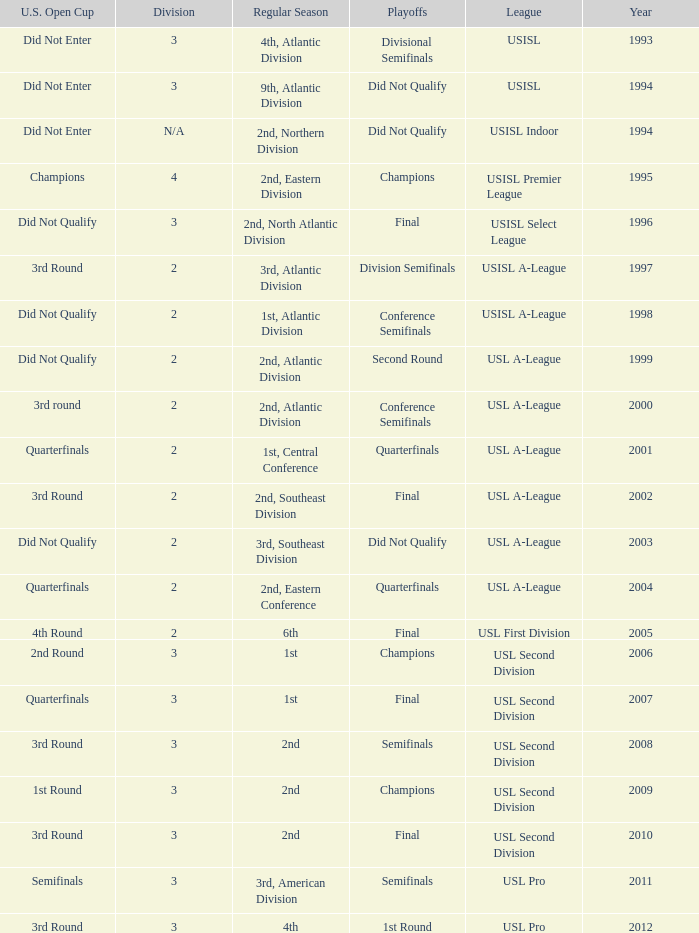What are all the playoffs for u.s. open cup in 1st round Champions. 